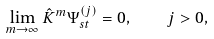Convert formula to latex. <formula><loc_0><loc_0><loc_500><loc_500>\lim _ { m \rightarrow \infty } \hat { K } ^ { m } \Psi _ { s t } ^ { \left ( j \right ) } = 0 , \quad j > 0 ,</formula> 